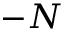Convert formula to latex. <formula><loc_0><loc_0><loc_500><loc_500>- N</formula> 